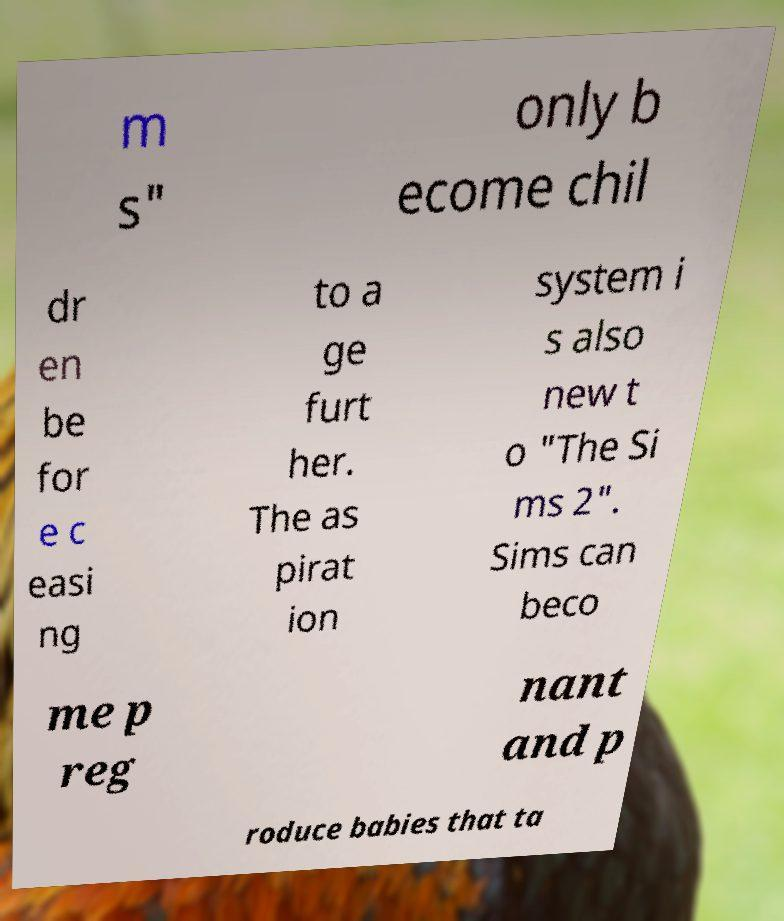There's text embedded in this image that I need extracted. Can you transcribe it verbatim? m s" only b ecome chil dr en be for e c easi ng to a ge furt her. The as pirat ion system i s also new t o "The Si ms 2". Sims can beco me p reg nant and p roduce babies that ta 